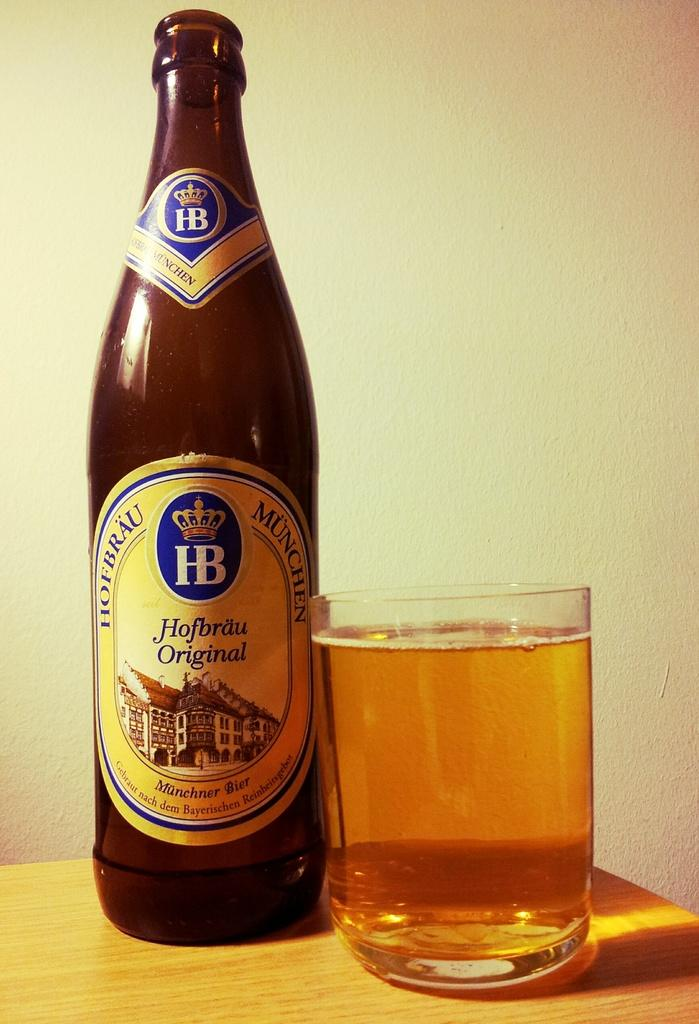<image>
Give a short and clear explanation of the subsequent image. Hofbrau Original tastes better poured into this glass with no ice 